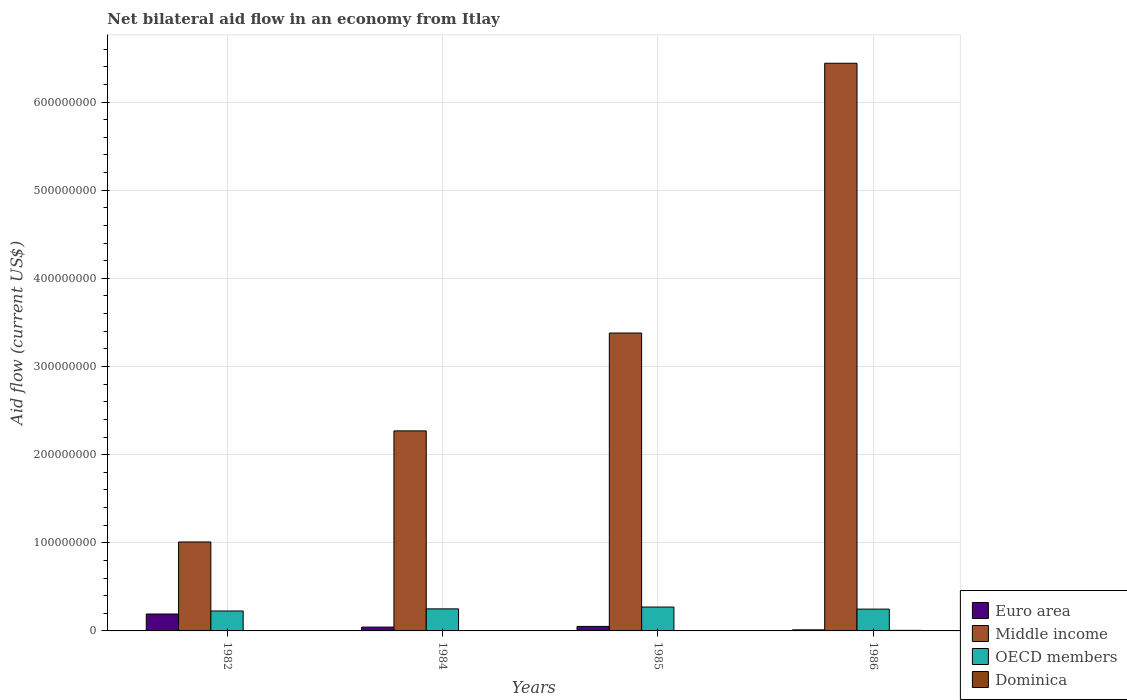Are the number of bars per tick equal to the number of legend labels?
Make the answer very short. Yes. How many bars are there on the 3rd tick from the left?
Make the answer very short. 4. What is the label of the 4th group of bars from the left?
Offer a very short reply. 1986. What is the net bilateral aid flow in Middle income in 1982?
Your response must be concise. 1.01e+08. Across all years, what is the maximum net bilateral aid flow in Dominica?
Offer a very short reply. 6.40e+05. Across all years, what is the minimum net bilateral aid flow in Dominica?
Provide a short and direct response. 3.00e+04. In which year was the net bilateral aid flow in Dominica maximum?
Give a very brief answer. 1986. What is the total net bilateral aid flow in Middle income in the graph?
Your answer should be very brief. 1.31e+09. What is the difference between the net bilateral aid flow in OECD members in 1985 and that in 1986?
Your answer should be very brief. 2.35e+06. What is the difference between the net bilateral aid flow in Dominica in 1985 and the net bilateral aid flow in OECD members in 1984?
Make the answer very short. -2.50e+07. What is the average net bilateral aid flow in OECD members per year?
Your answer should be compact. 2.49e+07. In the year 1985, what is the difference between the net bilateral aid flow in Dominica and net bilateral aid flow in Middle income?
Your answer should be compact. -3.38e+08. In how many years, is the net bilateral aid flow in Euro area greater than 60000000 US$?
Keep it short and to the point. 0. What is the ratio of the net bilateral aid flow in OECD members in 1982 to that in 1984?
Your response must be concise. 0.9. What is the difference between the highest and the second highest net bilateral aid flow in OECD members?
Your answer should be compact. 2.07e+06. What is the difference between the highest and the lowest net bilateral aid flow in OECD members?
Provide a succinct answer. 4.47e+06. Is the sum of the net bilateral aid flow in Middle income in 1984 and 1986 greater than the maximum net bilateral aid flow in Euro area across all years?
Keep it short and to the point. Yes. Is it the case that in every year, the sum of the net bilateral aid flow in Euro area and net bilateral aid flow in Middle income is greater than the sum of net bilateral aid flow in OECD members and net bilateral aid flow in Dominica?
Keep it short and to the point. No. What does the 2nd bar from the left in 1986 represents?
Your answer should be compact. Middle income. What does the 3rd bar from the right in 1984 represents?
Your answer should be very brief. Middle income. Is it the case that in every year, the sum of the net bilateral aid flow in Euro area and net bilateral aid flow in OECD members is greater than the net bilateral aid flow in Middle income?
Make the answer very short. No. Are all the bars in the graph horizontal?
Give a very brief answer. No. How many years are there in the graph?
Keep it short and to the point. 4. What is the difference between two consecutive major ticks on the Y-axis?
Your answer should be very brief. 1.00e+08. Are the values on the major ticks of Y-axis written in scientific E-notation?
Give a very brief answer. No. What is the title of the graph?
Your answer should be very brief. Net bilateral aid flow in an economy from Itlay. What is the label or title of the Y-axis?
Provide a short and direct response. Aid flow (current US$). What is the Aid flow (current US$) in Euro area in 1982?
Provide a succinct answer. 1.92e+07. What is the Aid flow (current US$) in Middle income in 1982?
Keep it short and to the point. 1.01e+08. What is the Aid flow (current US$) in OECD members in 1982?
Keep it short and to the point. 2.26e+07. What is the Aid flow (current US$) of Dominica in 1982?
Keep it short and to the point. 3.00e+04. What is the Aid flow (current US$) in Euro area in 1984?
Provide a succinct answer. 4.33e+06. What is the Aid flow (current US$) in Middle income in 1984?
Give a very brief answer. 2.27e+08. What is the Aid flow (current US$) of OECD members in 1984?
Provide a succinct answer. 2.50e+07. What is the Aid flow (current US$) of Euro area in 1985?
Provide a succinct answer. 5.11e+06. What is the Aid flow (current US$) of Middle income in 1985?
Make the answer very short. 3.38e+08. What is the Aid flow (current US$) in OECD members in 1985?
Your answer should be compact. 2.71e+07. What is the Aid flow (current US$) of Dominica in 1985?
Your response must be concise. 4.00e+04. What is the Aid flow (current US$) of Euro area in 1986?
Provide a succinct answer. 1.22e+06. What is the Aid flow (current US$) in Middle income in 1986?
Keep it short and to the point. 6.44e+08. What is the Aid flow (current US$) of OECD members in 1986?
Your response must be concise. 2.47e+07. What is the Aid flow (current US$) of Dominica in 1986?
Offer a terse response. 6.40e+05. Across all years, what is the maximum Aid flow (current US$) in Euro area?
Give a very brief answer. 1.92e+07. Across all years, what is the maximum Aid flow (current US$) of Middle income?
Make the answer very short. 6.44e+08. Across all years, what is the maximum Aid flow (current US$) in OECD members?
Offer a terse response. 2.71e+07. Across all years, what is the maximum Aid flow (current US$) of Dominica?
Provide a short and direct response. 6.40e+05. Across all years, what is the minimum Aid flow (current US$) of Euro area?
Keep it short and to the point. 1.22e+06. Across all years, what is the minimum Aid flow (current US$) of Middle income?
Your response must be concise. 1.01e+08. Across all years, what is the minimum Aid flow (current US$) of OECD members?
Your response must be concise. 2.26e+07. Across all years, what is the minimum Aid flow (current US$) in Dominica?
Your response must be concise. 3.00e+04. What is the total Aid flow (current US$) of Euro area in the graph?
Your answer should be compact. 2.98e+07. What is the total Aid flow (current US$) in Middle income in the graph?
Offer a very short reply. 1.31e+09. What is the total Aid flow (current US$) in OECD members in the graph?
Keep it short and to the point. 9.95e+07. What is the total Aid flow (current US$) of Dominica in the graph?
Your answer should be compact. 8.40e+05. What is the difference between the Aid flow (current US$) of Euro area in 1982 and that in 1984?
Offer a terse response. 1.48e+07. What is the difference between the Aid flow (current US$) of Middle income in 1982 and that in 1984?
Your response must be concise. -1.26e+08. What is the difference between the Aid flow (current US$) in OECD members in 1982 and that in 1984?
Ensure brevity in your answer.  -2.40e+06. What is the difference between the Aid flow (current US$) of Euro area in 1982 and that in 1985?
Ensure brevity in your answer.  1.41e+07. What is the difference between the Aid flow (current US$) of Middle income in 1982 and that in 1985?
Keep it short and to the point. -2.37e+08. What is the difference between the Aid flow (current US$) of OECD members in 1982 and that in 1985?
Keep it short and to the point. -4.47e+06. What is the difference between the Aid flow (current US$) in Euro area in 1982 and that in 1986?
Keep it short and to the point. 1.80e+07. What is the difference between the Aid flow (current US$) in Middle income in 1982 and that in 1986?
Ensure brevity in your answer.  -5.43e+08. What is the difference between the Aid flow (current US$) of OECD members in 1982 and that in 1986?
Ensure brevity in your answer.  -2.12e+06. What is the difference between the Aid flow (current US$) in Dominica in 1982 and that in 1986?
Give a very brief answer. -6.10e+05. What is the difference between the Aid flow (current US$) of Euro area in 1984 and that in 1985?
Your answer should be very brief. -7.80e+05. What is the difference between the Aid flow (current US$) of Middle income in 1984 and that in 1985?
Offer a very short reply. -1.11e+08. What is the difference between the Aid flow (current US$) in OECD members in 1984 and that in 1985?
Provide a succinct answer. -2.07e+06. What is the difference between the Aid flow (current US$) of Dominica in 1984 and that in 1985?
Ensure brevity in your answer.  9.00e+04. What is the difference between the Aid flow (current US$) in Euro area in 1984 and that in 1986?
Your answer should be compact. 3.11e+06. What is the difference between the Aid flow (current US$) of Middle income in 1984 and that in 1986?
Your response must be concise. -4.17e+08. What is the difference between the Aid flow (current US$) of Dominica in 1984 and that in 1986?
Your answer should be very brief. -5.10e+05. What is the difference between the Aid flow (current US$) of Euro area in 1985 and that in 1986?
Keep it short and to the point. 3.89e+06. What is the difference between the Aid flow (current US$) in Middle income in 1985 and that in 1986?
Offer a very short reply. -3.06e+08. What is the difference between the Aid flow (current US$) of OECD members in 1985 and that in 1986?
Your answer should be very brief. 2.35e+06. What is the difference between the Aid flow (current US$) of Dominica in 1985 and that in 1986?
Ensure brevity in your answer.  -6.00e+05. What is the difference between the Aid flow (current US$) in Euro area in 1982 and the Aid flow (current US$) in Middle income in 1984?
Keep it short and to the point. -2.08e+08. What is the difference between the Aid flow (current US$) of Euro area in 1982 and the Aid flow (current US$) of OECD members in 1984?
Your answer should be very brief. -5.84e+06. What is the difference between the Aid flow (current US$) of Euro area in 1982 and the Aid flow (current US$) of Dominica in 1984?
Your response must be concise. 1.90e+07. What is the difference between the Aid flow (current US$) in Middle income in 1982 and the Aid flow (current US$) in OECD members in 1984?
Offer a very short reply. 7.59e+07. What is the difference between the Aid flow (current US$) of Middle income in 1982 and the Aid flow (current US$) of Dominica in 1984?
Your answer should be compact. 1.01e+08. What is the difference between the Aid flow (current US$) of OECD members in 1982 and the Aid flow (current US$) of Dominica in 1984?
Your response must be concise. 2.25e+07. What is the difference between the Aid flow (current US$) of Euro area in 1982 and the Aid flow (current US$) of Middle income in 1985?
Provide a short and direct response. -3.19e+08. What is the difference between the Aid flow (current US$) in Euro area in 1982 and the Aid flow (current US$) in OECD members in 1985?
Offer a very short reply. -7.91e+06. What is the difference between the Aid flow (current US$) of Euro area in 1982 and the Aid flow (current US$) of Dominica in 1985?
Provide a short and direct response. 1.91e+07. What is the difference between the Aid flow (current US$) in Middle income in 1982 and the Aid flow (current US$) in OECD members in 1985?
Ensure brevity in your answer.  7.38e+07. What is the difference between the Aid flow (current US$) of Middle income in 1982 and the Aid flow (current US$) of Dominica in 1985?
Your answer should be very brief. 1.01e+08. What is the difference between the Aid flow (current US$) of OECD members in 1982 and the Aid flow (current US$) of Dominica in 1985?
Offer a terse response. 2.26e+07. What is the difference between the Aid flow (current US$) of Euro area in 1982 and the Aid flow (current US$) of Middle income in 1986?
Keep it short and to the point. -6.25e+08. What is the difference between the Aid flow (current US$) of Euro area in 1982 and the Aid flow (current US$) of OECD members in 1986?
Provide a succinct answer. -5.56e+06. What is the difference between the Aid flow (current US$) of Euro area in 1982 and the Aid flow (current US$) of Dominica in 1986?
Offer a terse response. 1.85e+07. What is the difference between the Aid flow (current US$) of Middle income in 1982 and the Aid flow (current US$) of OECD members in 1986?
Your answer should be very brief. 7.62e+07. What is the difference between the Aid flow (current US$) in Middle income in 1982 and the Aid flow (current US$) in Dominica in 1986?
Give a very brief answer. 1.00e+08. What is the difference between the Aid flow (current US$) of OECD members in 1982 and the Aid flow (current US$) of Dominica in 1986?
Your answer should be compact. 2.20e+07. What is the difference between the Aid flow (current US$) in Euro area in 1984 and the Aid flow (current US$) in Middle income in 1985?
Offer a very short reply. -3.34e+08. What is the difference between the Aid flow (current US$) in Euro area in 1984 and the Aid flow (current US$) in OECD members in 1985?
Your answer should be compact. -2.28e+07. What is the difference between the Aid flow (current US$) of Euro area in 1984 and the Aid flow (current US$) of Dominica in 1985?
Provide a succinct answer. 4.29e+06. What is the difference between the Aid flow (current US$) in Middle income in 1984 and the Aid flow (current US$) in OECD members in 1985?
Offer a very short reply. 2.00e+08. What is the difference between the Aid flow (current US$) of Middle income in 1984 and the Aid flow (current US$) of Dominica in 1985?
Make the answer very short. 2.27e+08. What is the difference between the Aid flow (current US$) of OECD members in 1984 and the Aid flow (current US$) of Dominica in 1985?
Your answer should be compact. 2.50e+07. What is the difference between the Aid flow (current US$) of Euro area in 1984 and the Aid flow (current US$) of Middle income in 1986?
Offer a very short reply. -6.40e+08. What is the difference between the Aid flow (current US$) in Euro area in 1984 and the Aid flow (current US$) in OECD members in 1986?
Offer a very short reply. -2.04e+07. What is the difference between the Aid flow (current US$) in Euro area in 1984 and the Aid flow (current US$) in Dominica in 1986?
Ensure brevity in your answer.  3.69e+06. What is the difference between the Aid flow (current US$) of Middle income in 1984 and the Aid flow (current US$) of OECD members in 1986?
Keep it short and to the point. 2.02e+08. What is the difference between the Aid flow (current US$) in Middle income in 1984 and the Aid flow (current US$) in Dominica in 1986?
Offer a terse response. 2.26e+08. What is the difference between the Aid flow (current US$) of OECD members in 1984 and the Aid flow (current US$) of Dominica in 1986?
Ensure brevity in your answer.  2.44e+07. What is the difference between the Aid flow (current US$) of Euro area in 1985 and the Aid flow (current US$) of Middle income in 1986?
Make the answer very short. -6.39e+08. What is the difference between the Aid flow (current US$) in Euro area in 1985 and the Aid flow (current US$) in OECD members in 1986?
Your response must be concise. -1.96e+07. What is the difference between the Aid flow (current US$) in Euro area in 1985 and the Aid flow (current US$) in Dominica in 1986?
Give a very brief answer. 4.47e+06. What is the difference between the Aid flow (current US$) in Middle income in 1985 and the Aid flow (current US$) in OECD members in 1986?
Ensure brevity in your answer.  3.13e+08. What is the difference between the Aid flow (current US$) of Middle income in 1985 and the Aid flow (current US$) of Dominica in 1986?
Your answer should be very brief. 3.37e+08. What is the difference between the Aid flow (current US$) of OECD members in 1985 and the Aid flow (current US$) of Dominica in 1986?
Keep it short and to the point. 2.64e+07. What is the average Aid flow (current US$) of Euro area per year?
Make the answer very short. 7.46e+06. What is the average Aid flow (current US$) in Middle income per year?
Give a very brief answer. 3.27e+08. What is the average Aid flow (current US$) of OECD members per year?
Your answer should be very brief. 2.49e+07. What is the average Aid flow (current US$) of Dominica per year?
Give a very brief answer. 2.10e+05. In the year 1982, what is the difference between the Aid flow (current US$) of Euro area and Aid flow (current US$) of Middle income?
Offer a very short reply. -8.17e+07. In the year 1982, what is the difference between the Aid flow (current US$) of Euro area and Aid flow (current US$) of OECD members?
Ensure brevity in your answer.  -3.44e+06. In the year 1982, what is the difference between the Aid flow (current US$) in Euro area and Aid flow (current US$) in Dominica?
Provide a succinct answer. 1.92e+07. In the year 1982, what is the difference between the Aid flow (current US$) of Middle income and Aid flow (current US$) of OECD members?
Ensure brevity in your answer.  7.83e+07. In the year 1982, what is the difference between the Aid flow (current US$) in Middle income and Aid flow (current US$) in Dominica?
Offer a very short reply. 1.01e+08. In the year 1982, what is the difference between the Aid flow (current US$) in OECD members and Aid flow (current US$) in Dominica?
Give a very brief answer. 2.26e+07. In the year 1984, what is the difference between the Aid flow (current US$) of Euro area and Aid flow (current US$) of Middle income?
Ensure brevity in your answer.  -2.23e+08. In the year 1984, what is the difference between the Aid flow (current US$) of Euro area and Aid flow (current US$) of OECD members?
Offer a terse response. -2.07e+07. In the year 1984, what is the difference between the Aid flow (current US$) of Euro area and Aid flow (current US$) of Dominica?
Ensure brevity in your answer.  4.20e+06. In the year 1984, what is the difference between the Aid flow (current US$) in Middle income and Aid flow (current US$) in OECD members?
Ensure brevity in your answer.  2.02e+08. In the year 1984, what is the difference between the Aid flow (current US$) in Middle income and Aid flow (current US$) in Dominica?
Give a very brief answer. 2.27e+08. In the year 1984, what is the difference between the Aid flow (current US$) of OECD members and Aid flow (current US$) of Dominica?
Give a very brief answer. 2.49e+07. In the year 1985, what is the difference between the Aid flow (current US$) of Euro area and Aid flow (current US$) of Middle income?
Your response must be concise. -3.33e+08. In the year 1985, what is the difference between the Aid flow (current US$) of Euro area and Aid flow (current US$) of OECD members?
Provide a short and direct response. -2.20e+07. In the year 1985, what is the difference between the Aid flow (current US$) in Euro area and Aid flow (current US$) in Dominica?
Offer a very short reply. 5.07e+06. In the year 1985, what is the difference between the Aid flow (current US$) of Middle income and Aid flow (current US$) of OECD members?
Your answer should be very brief. 3.11e+08. In the year 1985, what is the difference between the Aid flow (current US$) in Middle income and Aid flow (current US$) in Dominica?
Make the answer very short. 3.38e+08. In the year 1985, what is the difference between the Aid flow (current US$) of OECD members and Aid flow (current US$) of Dominica?
Offer a very short reply. 2.70e+07. In the year 1986, what is the difference between the Aid flow (current US$) of Euro area and Aid flow (current US$) of Middle income?
Give a very brief answer. -6.43e+08. In the year 1986, what is the difference between the Aid flow (current US$) in Euro area and Aid flow (current US$) in OECD members?
Give a very brief answer. -2.35e+07. In the year 1986, what is the difference between the Aid flow (current US$) of Euro area and Aid flow (current US$) of Dominica?
Ensure brevity in your answer.  5.80e+05. In the year 1986, what is the difference between the Aid flow (current US$) of Middle income and Aid flow (current US$) of OECD members?
Give a very brief answer. 6.19e+08. In the year 1986, what is the difference between the Aid flow (current US$) of Middle income and Aid flow (current US$) of Dominica?
Keep it short and to the point. 6.43e+08. In the year 1986, what is the difference between the Aid flow (current US$) in OECD members and Aid flow (current US$) in Dominica?
Provide a succinct answer. 2.41e+07. What is the ratio of the Aid flow (current US$) of Euro area in 1982 to that in 1984?
Provide a short and direct response. 4.43. What is the ratio of the Aid flow (current US$) of Middle income in 1982 to that in 1984?
Provide a short and direct response. 0.44. What is the ratio of the Aid flow (current US$) in OECD members in 1982 to that in 1984?
Keep it short and to the point. 0.9. What is the ratio of the Aid flow (current US$) of Dominica in 1982 to that in 1984?
Keep it short and to the point. 0.23. What is the ratio of the Aid flow (current US$) of Euro area in 1982 to that in 1985?
Your answer should be compact. 3.75. What is the ratio of the Aid flow (current US$) of Middle income in 1982 to that in 1985?
Provide a succinct answer. 0.3. What is the ratio of the Aid flow (current US$) in OECD members in 1982 to that in 1985?
Your answer should be compact. 0.83. What is the ratio of the Aid flow (current US$) of Dominica in 1982 to that in 1985?
Your answer should be compact. 0.75. What is the ratio of the Aid flow (current US$) of Euro area in 1982 to that in 1986?
Ensure brevity in your answer.  15.72. What is the ratio of the Aid flow (current US$) of Middle income in 1982 to that in 1986?
Give a very brief answer. 0.16. What is the ratio of the Aid flow (current US$) in OECD members in 1982 to that in 1986?
Give a very brief answer. 0.91. What is the ratio of the Aid flow (current US$) of Dominica in 1982 to that in 1986?
Provide a succinct answer. 0.05. What is the ratio of the Aid flow (current US$) in Euro area in 1984 to that in 1985?
Ensure brevity in your answer.  0.85. What is the ratio of the Aid flow (current US$) in Middle income in 1984 to that in 1985?
Give a very brief answer. 0.67. What is the ratio of the Aid flow (current US$) of OECD members in 1984 to that in 1985?
Offer a terse response. 0.92. What is the ratio of the Aid flow (current US$) in Euro area in 1984 to that in 1986?
Ensure brevity in your answer.  3.55. What is the ratio of the Aid flow (current US$) of Middle income in 1984 to that in 1986?
Your answer should be compact. 0.35. What is the ratio of the Aid flow (current US$) of OECD members in 1984 to that in 1986?
Provide a short and direct response. 1.01. What is the ratio of the Aid flow (current US$) in Dominica in 1984 to that in 1986?
Your answer should be compact. 0.2. What is the ratio of the Aid flow (current US$) in Euro area in 1985 to that in 1986?
Offer a very short reply. 4.19. What is the ratio of the Aid flow (current US$) of Middle income in 1985 to that in 1986?
Offer a terse response. 0.52. What is the ratio of the Aid flow (current US$) in OECD members in 1985 to that in 1986?
Provide a succinct answer. 1.09. What is the ratio of the Aid flow (current US$) in Dominica in 1985 to that in 1986?
Offer a very short reply. 0.06. What is the difference between the highest and the second highest Aid flow (current US$) in Euro area?
Give a very brief answer. 1.41e+07. What is the difference between the highest and the second highest Aid flow (current US$) in Middle income?
Offer a terse response. 3.06e+08. What is the difference between the highest and the second highest Aid flow (current US$) of OECD members?
Provide a short and direct response. 2.07e+06. What is the difference between the highest and the second highest Aid flow (current US$) of Dominica?
Keep it short and to the point. 5.10e+05. What is the difference between the highest and the lowest Aid flow (current US$) in Euro area?
Offer a terse response. 1.80e+07. What is the difference between the highest and the lowest Aid flow (current US$) in Middle income?
Your answer should be very brief. 5.43e+08. What is the difference between the highest and the lowest Aid flow (current US$) of OECD members?
Make the answer very short. 4.47e+06. 